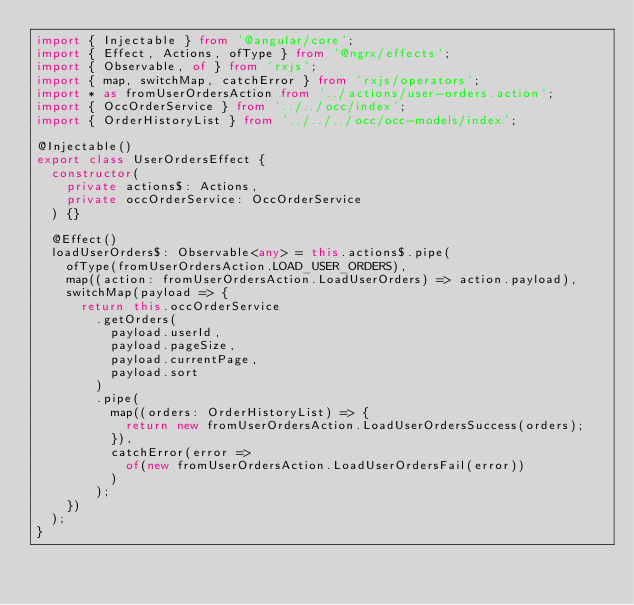Convert code to text. <code><loc_0><loc_0><loc_500><loc_500><_TypeScript_>import { Injectable } from '@angular/core';
import { Effect, Actions, ofType } from '@ngrx/effects';
import { Observable, of } from 'rxjs';
import { map, switchMap, catchError } from 'rxjs/operators';
import * as fromUserOrdersAction from '../actions/user-orders.action';
import { OccOrderService } from '../../occ/index';
import { OrderHistoryList } from '../../../occ/occ-models/index';

@Injectable()
export class UserOrdersEffect {
  constructor(
    private actions$: Actions,
    private occOrderService: OccOrderService
  ) {}

  @Effect()
  loadUserOrders$: Observable<any> = this.actions$.pipe(
    ofType(fromUserOrdersAction.LOAD_USER_ORDERS),
    map((action: fromUserOrdersAction.LoadUserOrders) => action.payload),
    switchMap(payload => {
      return this.occOrderService
        .getOrders(
          payload.userId,
          payload.pageSize,
          payload.currentPage,
          payload.sort
        )
        .pipe(
          map((orders: OrderHistoryList) => {
            return new fromUserOrdersAction.LoadUserOrdersSuccess(orders);
          }),
          catchError(error =>
            of(new fromUserOrdersAction.LoadUserOrdersFail(error))
          )
        );
    })
  );
}
</code> 